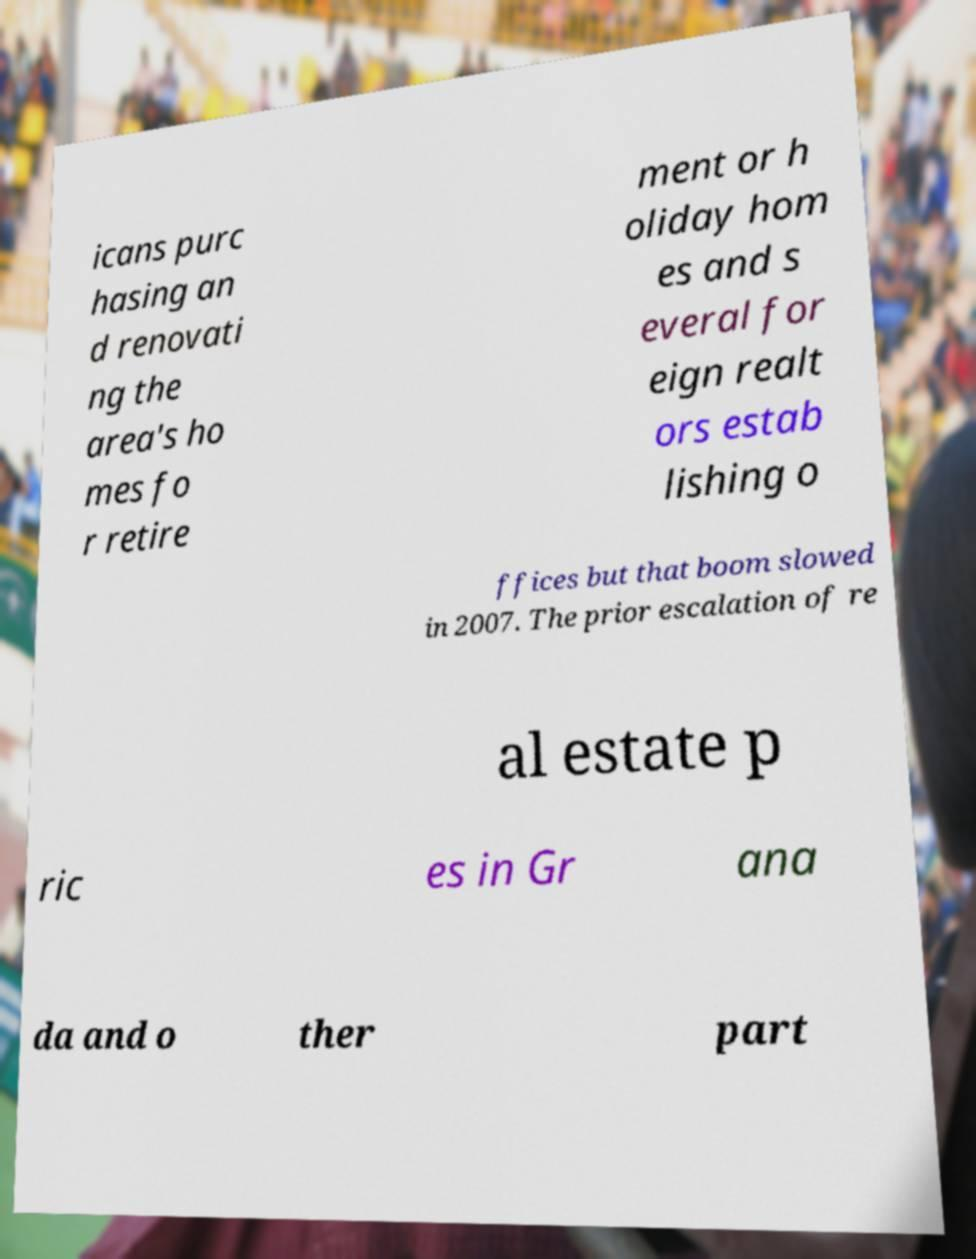I need the written content from this picture converted into text. Can you do that? icans purc hasing an d renovati ng the area's ho mes fo r retire ment or h oliday hom es and s everal for eign realt ors estab lishing o ffices but that boom slowed in 2007. The prior escalation of re al estate p ric es in Gr ana da and o ther part 